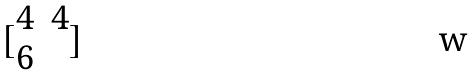Convert formula to latex. <formula><loc_0><loc_0><loc_500><loc_500>[ \begin{matrix} 4 & 4 \\ 6 \end{matrix} ]</formula> 